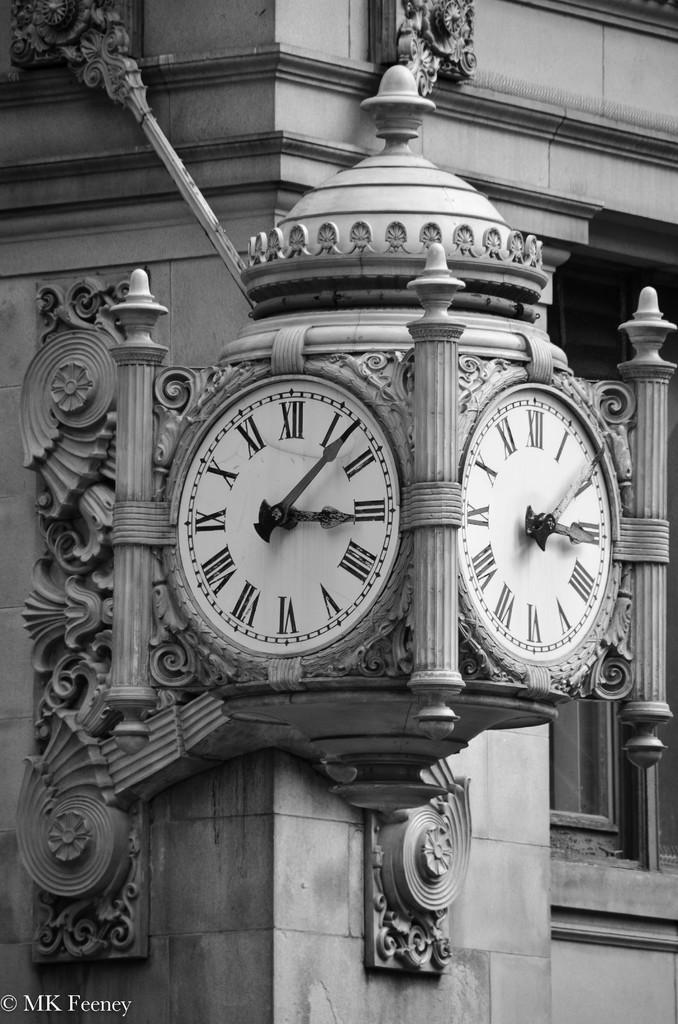<image>
Provide a brief description of the given image. A clock on the corner of a building shows the time of 3:08. 